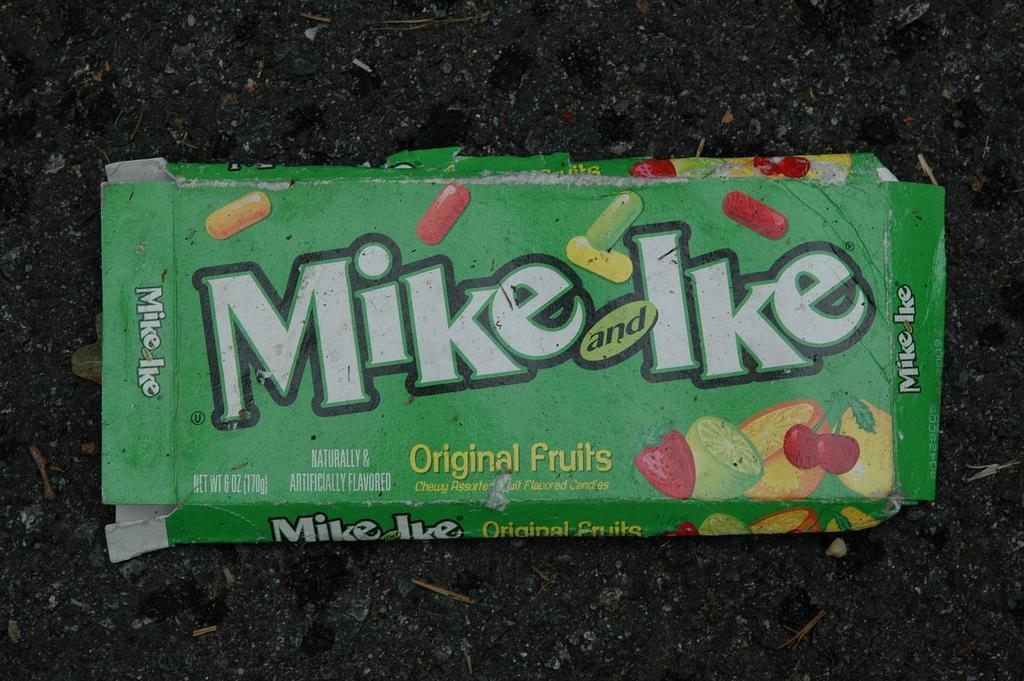What object can be seen in the image? There is an empty candy wrapper in the image. What might have been contained in the wrapper before it was empty? The wrapper might have contained candy before it was empty. Can you describe the condition of the wrapper in the image? The wrapper is empty and discarded in the image. How many snakes are slithering on the pump in the image? There are no snakes or pumps present in the image; it only features an empty candy wrapper. 